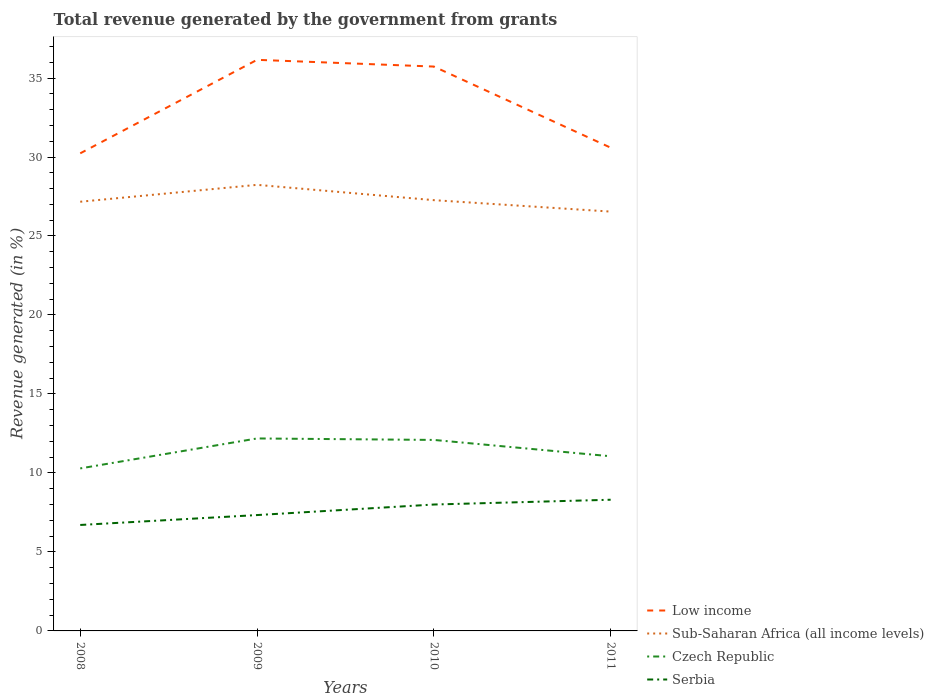Is the number of lines equal to the number of legend labels?
Offer a very short reply. Yes. Across all years, what is the maximum total revenue generated in Sub-Saharan Africa (all income levels)?
Make the answer very short. 26.54. What is the total total revenue generated in Czech Republic in the graph?
Ensure brevity in your answer.  -1.9. What is the difference between the highest and the second highest total revenue generated in Czech Republic?
Make the answer very short. 1.9. Is the total revenue generated in Sub-Saharan Africa (all income levels) strictly greater than the total revenue generated in Serbia over the years?
Offer a terse response. No. How many years are there in the graph?
Ensure brevity in your answer.  4. What is the difference between two consecutive major ticks on the Y-axis?
Offer a very short reply. 5. Does the graph contain grids?
Offer a terse response. No. Where does the legend appear in the graph?
Offer a very short reply. Bottom right. How many legend labels are there?
Give a very brief answer. 4. What is the title of the graph?
Your response must be concise. Total revenue generated by the government from grants. Does "United States" appear as one of the legend labels in the graph?
Provide a short and direct response. No. What is the label or title of the Y-axis?
Your answer should be compact. Revenue generated (in %). What is the Revenue generated (in %) in Low income in 2008?
Give a very brief answer. 30.23. What is the Revenue generated (in %) in Sub-Saharan Africa (all income levels) in 2008?
Offer a very short reply. 27.17. What is the Revenue generated (in %) in Czech Republic in 2008?
Your answer should be very brief. 10.29. What is the Revenue generated (in %) in Serbia in 2008?
Ensure brevity in your answer.  6.71. What is the Revenue generated (in %) of Low income in 2009?
Your response must be concise. 36.15. What is the Revenue generated (in %) of Sub-Saharan Africa (all income levels) in 2009?
Give a very brief answer. 28.24. What is the Revenue generated (in %) of Czech Republic in 2009?
Provide a short and direct response. 12.18. What is the Revenue generated (in %) of Serbia in 2009?
Offer a terse response. 7.33. What is the Revenue generated (in %) in Low income in 2010?
Keep it short and to the point. 35.73. What is the Revenue generated (in %) of Sub-Saharan Africa (all income levels) in 2010?
Ensure brevity in your answer.  27.27. What is the Revenue generated (in %) in Czech Republic in 2010?
Provide a succinct answer. 12.09. What is the Revenue generated (in %) of Serbia in 2010?
Give a very brief answer. 8. What is the Revenue generated (in %) of Low income in 2011?
Give a very brief answer. 30.59. What is the Revenue generated (in %) in Sub-Saharan Africa (all income levels) in 2011?
Make the answer very short. 26.54. What is the Revenue generated (in %) of Czech Republic in 2011?
Provide a succinct answer. 11.06. What is the Revenue generated (in %) of Serbia in 2011?
Provide a succinct answer. 8.3. Across all years, what is the maximum Revenue generated (in %) of Low income?
Provide a succinct answer. 36.15. Across all years, what is the maximum Revenue generated (in %) of Sub-Saharan Africa (all income levels)?
Ensure brevity in your answer.  28.24. Across all years, what is the maximum Revenue generated (in %) in Czech Republic?
Your answer should be very brief. 12.18. Across all years, what is the maximum Revenue generated (in %) of Serbia?
Provide a short and direct response. 8.3. Across all years, what is the minimum Revenue generated (in %) in Low income?
Provide a short and direct response. 30.23. Across all years, what is the minimum Revenue generated (in %) in Sub-Saharan Africa (all income levels)?
Make the answer very short. 26.54. Across all years, what is the minimum Revenue generated (in %) in Czech Republic?
Offer a very short reply. 10.29. Across all years, what is the minimum Revenue generated (in %) of Serbia?
Your answer should be very brief. 6.71. What is the total Revenue generated (in %) of Low income in the graph?
Ensure brevity in your answer.  132.7. What is the total Revenue generated (in %) of Sub-Saharan Africa (all income levels) in the graph?
Keep it short and to the point. 109.22. What is the total Revenue generated (in %) in Czech Republic in the graph?
Keep it short and to the point. 45.62. What is the total Revenue generated (in %) of Serbia in the graph?
Offer a very short reply. 30.35. What is the difference between the Revenue generated (in %) in Low income in 2008 and that in 2009?
Make the answer very short. -5.92. What is the difference between the Revenue generated (in %) of Sub-Saharan Africa (all income levels) in 2008 and that in 2009?
Your response must be concise. -1.07. What is the difference between the Revenue generated (in %) in Czech Republic in 2008 and that in 2009?
Offer a very short reply. -1.9. What is the difference between the Revenue generated (in %) of Serbia in 2008 and that in 2009?
Provide a short and direct response. -0.63. What is the difference between the Revenue generated (in %) of Low income in 2008 and that in 2010?
Provide a short and direct response. -5.49. What is the difference between the Revenue generated (in %) of Sub-Saharan Africa (all income levels) in 2008 and that in 2010?
Provide a short and direct response. -0.1. What is the difference between the Revenue generated (in %) in Czech Republic in 2008 and that in 2010?
Provide a succinct answer. -1.8. What is the difference between the Revenue generated (in %) in Serbia in 2008 and that in 2010?
Your response must be concise. -1.29. What is the difference between the Revenue generated (in %) in Low income in 2008 and that in 2011?
Offer a very short reply. -0.36. What is the difference between the Revenue generated (in %) in Sub-Saharan Africa (all income levels) in 2008 and that in 2011?
Make the answer very short. 0.62. What is the difference between the Revenue generated (in %) of Czech Republic in 2008 and that in 2011?
Provide a short and direct response. -0.77. What is the difference between the Revenue generated (in %) in Serbia in 2008 and that in 2011?
Provide a succinct answer. -1.6. What is the difference between the Revenue generated (in %) of Low income in 2009 and that in 2010?
Keep it short and to the point. 0.43. What is the difference between the Revenue generated (in %) of Sub-Saharan Africa (all income levels) in 2009 and that in 2010?
Ensure brevity in your answer.  0.97. What is the difference between the Revenue generated (in %) in Czech Republic in 2009 and that in 2010?
Give a very brief answer. 0.09. What is the difference between the Revenue generated (in %) in Serbia in 2009 and that in 2010?
Make the answer very short. -0.67. What is the difference between the Revenue generated (in %) of Low income in 2009 and that in 2011?
Offer a terse response. 5.56. What is the difference between the Revenue generated (in %) in Sub-Saharan Africa (all income levels) in 2009 and that in 2011?
Keep it short and to the point. 1.69. What is the difference between the Revenue generated (in %) of Czech Republic in 2009 and that in 2011?
Provide a short and direct response. 1.13. What is the difference between the Revenue generated (in %) of Serbia in 2009 and that in 2011?
Your answer should be very brief. -0.97. What is the difference between the Revenue generated (in %) in Low income in 2010 and that in 2011?
Keep it short and to the point. 5.13. What is the difference between the Revenue generated (in %) of Sub-Saharan Africa (all income levels) in 2010 and that in 2011?
Your answer should be very brief. 0.72. What is the difference between the Revenue generated (in %) of Czech Republic in 2010 and that in 2011?
Make the answer very short. 1.03. What is the difference between the Revenue generated (in %) in Serbia in 2010 and that in 2011?
Give a very brief answer. -0.3. What is the difference between the Revenue generated (in %) in Low income in 2008 and the Revenue generated (in %) in Sub-Saharan Africa (all income levels) in 2009?
Offer a terse response. 1.99. What is the difference between the Revenue generated (in %) in Low income in 2008 and the Revenue generated (in %) in Czech Republic in 2009?
Your answer should be very brief. 18.05. What is the difference between the Revenue generated (in %) of Low income in 2008 and the Revenue generated (in %) of Serbia in 2009?
Make the answer very short. 22.9. What is the difference between the Revenue generated (in %) in Sub-Saharan Africa (all income levels) in 2008 and the Revenue generated (in %) in Czech Republic in 2009?
Ensure brevity in your answer.  14.99. What is the difference between the Revenue generated (in %) of Sub-Saharan Africa (all income levels) in 2008 and the Revenue generated (in %) of Serbia in 2009?
Offer a terse response. 19.84. What is the difference between the Revenue generated (in %) of Czech Republic in 2008 and the Revenue generated (in %) of Serbia in 2009?
Ensure brevity in your answer.  2.95. What is the difference between the Revenue generated (in %) in Low income in 2008 and the Revenue generated (in %) in Sub-Saharan Africa (all income levels) in 2010?
Your answer should be very brief. 2.96. What is the difference between the Revenue generated (in %) of Low income in 2008 and the Revenue generated (in %) of Czech Republic in 2010?
Provide a short and direct response. 18.14. What is the difference between the Revenue generated (in %) in Low income in 2008 and the Revenue generated (in %) in Serbia in 2010?
Ensure brevity in your answer.  22.23. What is the difference between the Revenue generated (in %) in Sub-Saharan Africa (all income levels) in 2008 and the Revenue generated (in %) in Czech Republic in 2010?
Your answer should be very brief. 15.08. What is the difference between the Revenue generated (in %) in Sub-Saharan Africa (all income levels) in 2008 and the Revenue generated (in %) in Serbia in 2010?
Your response must be concise. 19.17. What is the difference between the Revenue generated (in %) in Czech Republic in 2008 and the Revenue generated (in %) in Serbia in 2010?
Provide a short and direct response. 2.29. What is the difference between the Revenue generated (in %) in Low income in 2008 and the Revenue generated (in %) in Sub-Saharan Africa (all income levels) in 2011?
Your response must be concise. 3.69. What is the difference between the Revenue generated (in %) in Low income in 2008 and the Revenue generated (in %) in Czech Republic in 2011?
Give a very brief answer. 19.18. What is the difference between the Revenue generated (in %) of Low income in 2008 and the Revenue generated (in %) of Serbia in 2011?
Keep it short and to the point. 21.93. What is the difference between the Revenue generated (in %) of Sub-Saharan Africa (all income levels) in 2008 and the Revenue generated (in %) of Czech Republic in 2011?
Provide a succinct answer. 16.11. What is the difference between the Revenue generated (in %) of Sub-Saharan Africa (all income levels) in 2008 and the Revenue generated (in %) of Serbia in 2011?
Give a very brief answer. 18.86. What is the difference between the Revenue generated (in %) in Czech Republic in 2008 and the Revenue generated (in %) in Serbia in 2011?
Offer a very short reply. 1.98. What is the difference between the Revenue generated (in %) of Low income in 2009 and the Revenue generated (in %) of Sub-Saharan Africa (all income levels) in 2010?
Give a very brief answer. 8.88. What is the difference between the Revenue generated (in %) in Low income in 2009 and the Revenue generated (in %) in Czech Republic in 2010?
Offer a terse response. 24.06. What is the difference between the Revenue generated (in %) in Low income in 2009 and the Revenue generated (in %) in Serbia in 2010?
Offer a terse response. 28.15. What is the difference between the Revenue generated (in %) of Sub-Saharan Africa (all income levels) in 2009 and the Revenue generated (in %) of Czech Republic in 2010?
Provide a short and direct response. 16.15. What is the difference between the Revenue generated (in %) of Sub-Saharan Africa (all income levels) in 2009 and the Revenue generated (in %) of Serbia in 2010?
Ensure brevity in your answer.  20.24. What is the difference between the Revenue generated (in %) of Czech Republic in 2009 and the Revenue generated (in %) of Serbia in 2010?
Your response must be concise. 4.18. What is the difference between the Revenue generated (in %) in Low income in 2009 and the Revenue generated (in %) in Sub-Saharan Africa (all income levels) in 2011?
Offer a very short reply. 9.61. What is the difference between the Revenue generated (in %) of Low income in 2009 and the Revenue generated (in %) of Czech Republic in 2011?
Your response must be concise. 25.1. What is the difference between the Revenue generated (in %) in Low income in 2009 and the Revenue generated (in %) in Serbia in 2011?
Keep it short and to the point. 27.85. What is the difference between the Revenue generated (in %) of Sub-Saharan Africa (all income levels) in 2009 and the Revenue generated (in %) of Czech Republic in 2011?
Provide a succinct answer. 17.18. What is the difference between the Revenue generated (in %) in Sub-Saharan Africa (all income levels) in 2009 and the Revenue generated (in %) in Serbia in 2011?
Offer a very short reply. 19.93. What is the difference between the Revenue generated (in %) of Czech Republic in 2009 and the Revenue generated (in %) of Serbia in 2011?
Ensure brevity in your answer.  3.88. What is the difference between the Revenue generated (in %) of Low income in 2010 and the Revenue generated (in %) of Sub-Saharan Africa (all income levels) in 2011?
Your answer should be compact. 9.18. What is the difference between the Revenue generated (in %) of Low income in 2010 and the Revenue generated (in %) of Czech Republic in 2011?
Ensure brevity in your answer.  24.67. What is the difference between the Revenue generated (in %) of Low income in 2010 and the Revenue generated (in %) of Serbia in 2011?
Offer a very short reply. 27.42. What is the difference between the Revenue generated (in %) in Sub-Saharan Africa (all income levels) in 2010 and the Revenue generated (in %) in Czech Republic in 2011?
Ensure brevity in your answer.  16.21. What is the difference between the Revenue generated (in %) in Sub-Saharan Africa (all income levels) in 2010 and the Revenue generated (in %) in Serbia in 2011?
Offer a very short reply. 18.96. What is the difference between the Revenue generated (in %) of Czech Republic in 2010 and the Revenue generated (in %) of Serbia in 2011?
Keep it short and to the point. 3.79. What is the average Revenue generated (in %) of Low income per year?
Make the answer very short. 33.18. What is the average Revenue generated (in %) in Sub-Saharan Africa (all income levels) per year?
Your response must be concise. 27.31. What is the average Revenue generated (in %) of Czech Republic per year?
Offer a terse response. 11.4. What is the average Revenue generated (in %) of Serbia per year?
Provide a short and direct response. 7.59. In the year 2008, what is the difference between the Revenue generated (in %) of Low income and Revenue generated (in %) of Sub-Saharan Africa (all income levels)?
Make the answer very short. 3.06. In the year 2008, what is the difference between the Revenue generated (in %) of Low income and Revenue generated (in %) of Czech Republic?
Your answer should be compact. 19.95. In the year 2008, what is the difference between the Revenue generated (in %) in Low income and Revenue generated (in %) in Serbia?
Offer a very short reply. 23.53. In the year 2008, what is the difference between the Revenue generated (in %) of Sub-Saharan Africa (all income levels) and Revenue generated (in %) of Czech Republic?
Your answer should be very brief. 16.88. In the year 2008, what is the difference between the Revenue generated (in %) in Sub-Saharan Africa (all income levels) and Revenue generated (in %) in Serbia?
Provide a short and direct response. 20.46. In the year 2008, what is the difference between the Revenue generated (in %) in Czech Republic and Revenue generated (in %) in Serbia?
Give a very brief answer. 3.58. In the year 2009, what is the difference between the Revenue generated (in %) of Low income and Revenue generated (in %) of Sub-Saharan Africa (all income levels)?
Offer a terse response. 7.91. In the year 2009, what is the difference between the Revenue generated (in %) of Low income and Revenue generated (in %) of Czech Republic?
Provide a short and direct response. 23.97. In the year 2009, what is the difference between the Revenue generated (in %) in Low income and Revenue generated (in %) in Serbia?
Make the answer very short. 28.82. In the year 2009, what is the difference between the Revenue generated (in %) in Sub-Saharan Africa (all income levels) and Revenue generated (in %) in Czech Republic?
Make the answer very short. 16.05. In the year 2009, what is the difference between the Revenue generated (in %) of Sub-Saharan Africa (all income levels) and Revenue generated (in %) of Serbia?
Give a very brief answer. 20.9. In the year 2009, what is the difference between the Revenue generated (in %) in Czech Republic and Revenue generated (in %) in Serbia?
Your answer should be compact. 4.85. In the year 2010, what is the difference between the Revenue generated (in %) of Low income and Revenue generated (in %) of Sub-Saharan Africa (all income levels)?
Your answer should be very brief. 8.46. In the year 2010, what is the difference between the Revenue generated (in %) of Low income and Revenue generated (in %) of Czech Republic?
Ensure brevity in your answer.  23.64. In the year 2010, what is the difference between the Revenue generated (in %) in Low income and Revenue generated (in %) in Serbia?
Your answer should be compact. 27.72. In the year 2010, what is the difference between the Revenue generated (in %) of Sub-Saharan Africa (all income levels) and Revenue generated (in %) of Czech Republic?
Offer a terse response. 15.18. In the year 2010, what is the difference between the Revenue generated (in %) of Sub-Saharan Africa (all income levels) and Revenue generated (in %) of Serbia?
Your answer should be very brief. 19.27. In the year 2010, what is the difference between the Revenue generated (in %) in Czech Republic and Revenue generated (in %) in Serbia?
Make the answer very short. 4.09. In the year 2011, what is the difference between the Revenue generated (in %) of Low income and Revenue generated (in %) of Sub-Saharan Africa (all income levels)?
Offer a terse response. 4.05. In the year 2011, what is the difference between the Revenue generated (in %) of Low income and Revenue generated (in %) of Czech Republic?
Give a very brief answer. 19.53. In the year 2011, what is the difference between the Revenue generated (in %) in Low income and Revenue generated (in %) in Serbia?
Provide a succinct answer. 22.29. In the year 2011, what is the difference between the Revenue generated (in %) of Sub-Saharan Africa (all income levels) and Revenue generated (in %) of Czech Republic?
Make the answer very short. 15.49. In the year 2011, what is the difference between the Revenue generated (in %) of Sub-Saharan Africa (all income levels) and Revenue generated (in %) of Serbia?
Keep it short and to the point. 18.24. In the year 2011, what is the difference between the Revenue generated (in %) in Czech Republic and Revenue generated (in %) in Serbia?
Give a very brief answer. 2.75. What is the ratio of the Revenue generated (in %) in Low income in 2008 to that in 2009?
Keep it short and to the point. 0.84. What is the ratio of the Revenue generated (in %) in Sub-Saharan Africa (all income levels) in 2008 to that in 2009?
Provide a succinct answer. 0.96. What is the ratio of the Revenue generated (in %) in Czech Republic in 2008 to that in 2009?
Ensure brevity in your answer.  0.84. What is the ratio of the Revenue generated (in %) in Serbia in 2008 to that in 2009?
Provide a short and direct response. 0.91. What is the ratio of the Revenue generated (in %) in Low income in 2008 to that in 2010?
Provide a succinct answer. 0.85. What is the ratio of the Revenue generated (in %) of Sub-Saharan Africa (all income levels) in 2008 to that in 2010?
Offer a terse response. 1. What is the ratio of the Revenue generated (in %) of Czech Republic in 2008 to that in 2010?
Offer a terse response. 0.85. What is the ratio of the Revenue generated (in %) in Serbia in 2008 to that in 2010?
Provide a short and direct response. 0.84. What is the ratio of the Revenue generated (in %) of Low income in 2008 to that in 2011?
Make the answer very short. 0.99. What is the ratio of the Revenue generated (in %) in Sub-Saharan Africa (all income levels) in 2008 to that in 2011?
Your response must be concise. 1.02. What is the ratio of the Revenue generated (in %) in Czech Republic in 2008 to that in 2011?
Provide a short and direct response. 0.93. What is the ratio of the Revenue generated (in %) of Serbia in 2008 to that in 2011?
Your answer should be very brief. 0.81. What is the ratio of the Revenue generated (in %) in Low income in 2009 to that in 2010?
Your answer should be very brief. 1.01. What is the ratio of the Revenue generated (in %) of Sub-Saharan Africa (all income levels) in 2009 to that in 2010?
Your answer should be compact. 1.04. What is the ratio of the Revenue generated (in %) of Czech Republic in 2009 to that in 2010?
Make the answer very short. 1.01. What is the ratio of the Revenue generated (in %) in Serbia in 2009 to that in 2010?
Ensure brevity in your answer.  0.92. What is the ratio of the Revenue generated (in %) of Low income in 2009 to that in 2011?
Give a very brief answer. 1.18. What is the ratio of the Revenue generated (in %) of Sub-Saharan Africa (all income levels) in 2009 to that in 2011?
Offer a terse response. 1.06. What is the ratio of the Revenue generated (in %) in Czech Republic in 2009 to that in 2011?
Give a very brief answer. 1.1. What is the ratio of the Revenue generated (in %) in Serbia in 2009 to that in 2011?
Offer a very short reply. 0.88. What is the ratio of the Revenue generated (in %) in Low income in 2010 to that in 2011?
Offer a terse response. 1.17. What is the ratio of the Revenue generated (in %) of Sub-Saharan Africa (all income levels) in 2010 to that in 2011?
Make the answer very short. 1.03. What is the ratio of the Revenue generated (in %) in Czech Republic in 2010 to that in 2011?
Ensure brevity in your answer.  1.09. What is the ratio of the Revenue generated (in %) of Serbia in 2010 to that in 2011?
Provide a short and direct response. 0.96. What is the difference between the highest and the second highest Revenue generated (in %) in Low income?
Offer a very short reply. 0.43. What is the difference between the highest and the second highest Revenue generated (in %) in Sub-Saharan Africa (all income levels)?
Keep it short and to the point. 0.97. What is the difference between the highest and the second highest Revenue generated (in %) in Czech Republic?
Make the answer very short. 0.09. What is the difference between the highest and the second highest Revenue generated (in %) of Serbia?
Your response must be concise. 0.3. What is the difference between the highest and the lowest Revenue generated (in %) in Low income?
Make the answer very short. 5.92. What is the difference between the highest and the lowest Revenue generated (in %) in Sub-Saharan Africa (all income levels)?
Keep it short and to the point. 1.69. What is the difference between the highest and the lowest Revenue generated (in %) in Czech Republic?
Keep it short and to the point. 1.9. What is the difference between the highest and the lowest Revenue generated (in %) of Serbia?
Provide a short and direct response. 1.6. 